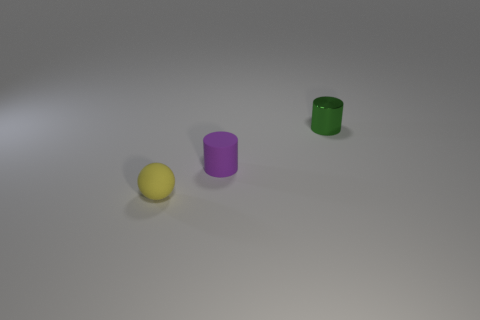How many objects are there in total? There are a total of three objects in the image: a tiny rubber sphere and two cylindrical objects. 